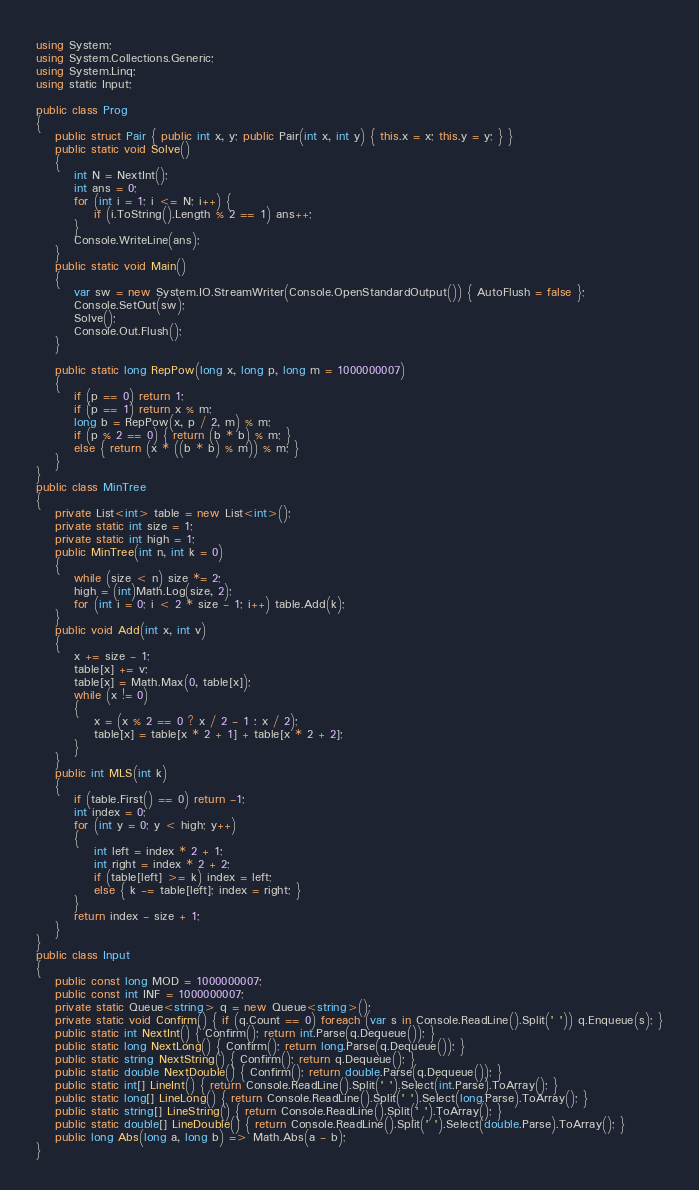<code> <loc_0><loc_0><loc_500><loc_500><_C#_>using System;
using System.Collections.Generic;
using System.Linq;
using static Input;

public class Prog
{
    public struct Pair { public int x, y; public Pair(int x, int y) { this.x = x; this.y = y; } }
    public static void Solve()
    {
        int N = NextInt();
        int ans = 0;
        for (int i = 1; i <= N; i++) {
            if (i.ToString().Length % 2 == 1) ans++;
        }
        Console.WriteLine(ans);
    }
    public static void Main()
    {
        var sw = new System.IO.StreamWriter(Console.OpenStandardOutput()) { AutoFlush = false };
        Console.SetOut(sw);
        Solve();
        Console.Out.Flush();
    }

    public static long RepPow(long x, long p, long m = 1000000007)
    {
        if (p == 0) return 1;
        if (p == 1) return x % m;
        long b = RepPow(x, p / 2, m) % m;
        if (p % 2 == 0) { return (b * b) % m; }
        else { return (x * ((b * b) % m)) % m; }
    }
}
public class MinTree
{
    private List<int> table = new List<int>();
    private static int size = 1;
    private static int high = 1;
    public MinTree(int n, int k = 0)
    {
        while (size < n) size *= 2;
        high = (int)Math.Log(size, 2);
        for (int i = 0; i < 2 * size - 1; i++) table.Add(k);
    }
    public void Add(int x, int v)
    {
        x += size - 1;
        table[x] += v;
        table[x] = Math.Max(0, table[x]);
        while (x != 0)
        {
            x = (x % 2 == 0 ? x / 2 - 1 : x / 2);
            table[x] = table[x * 2 + 1] + table[x * 2 + 2];
        }
    }
    public int MLS(int k)
    {
        if (table.First() == 0) return -1;
        int index = 0;
        for (int y = 0; y < high; y++)
        {
            int left = index * 2 + 1;
            int right = index * 2 + 2;
            if (table[left] >= k) index = left;
            else { k -= table[left]; index = right; }
        }
        return index - size + 1;
    }
}
public class Input
{
    public const long MOD = 1000000007;
    public const int INF = 1000000007;
    private static Queue<string> q = new Queue<string>();
    private static void Confirm() { if (q.Count == 0) foreach (var s in Console.ReadLine().Split(' ')) q.Enqueue(s); }
    public static int NextInt() { Confirm(); return int.Parse(q.Dequeue()); }
    public static long NextLong() { Confirm(); return long.Parse(q.Dequeue()); }
    public static string NextString() { Confirm(); return q.Dequeue(); }
    public static double NextDouble() { Confirm(); return double.Parse(q.Dequeue()); }
    public static int[] LineInt() { return Console.ReadLine().Split(' ').Select(int.Parse).ToArray(); }
    public static long[] LineLong() { return Console.ReadLine().Split(' ').Select(long.Parse).ToArray(); }
    public static string[] LineString() { return Console.ReadLine().Split(' ').ToArray(); }
    public static double[] LineDouble() { return Console.ReadLine().Split(' ').Select(double.Parse).ToArray(); }
    public long Abs(long a, long b) => Math.Abs(a - b);
}
</code> 